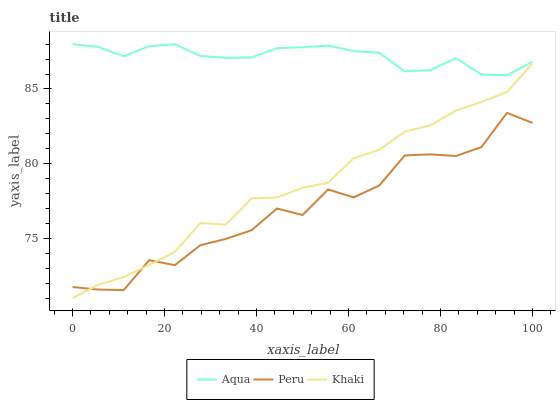Does Peru have the minimum area under the curve?
Answer yes or no. Yes. Does Aqua have the maximum area under the curve?
Answer yes or no. Yes. Does Aqua have the minimum area under the curve?
Answer yes or no. No. Does Peru have the maximum area under the curve?
Answer yes or no. No. Is Aqua the smoothest?
Answer yes or no. Yes. Is Peru the roughest?
Answer yes or no. Yes. Is Peru the smoothest?
Answer yes or no. No. Is Aqua the roughest?
Answer yes or no. No. Does Khaki have the lowest value?
Answer yes or no. Yes. Does Peru have the lowest value?
Answer yes or no. No. Does Aqua have the highest value?
Answer yes or no. Yes. Does Peru have the highest value?
Answer yes or no. No. Is Khaki less than Aqua?
Answer yes or no. Yes. Is Aqua greater than Peru?
Answer yes or no. Yes. Does Peru intersect Khaki?
Answer yes or no. Yes. Is Peru less than Khaki?
Answer yes or no. No. Is Peru greater than Khaki?
Answer yes or no. No. Does Khaki intersect Aqua?
Answer yes or no. No. 